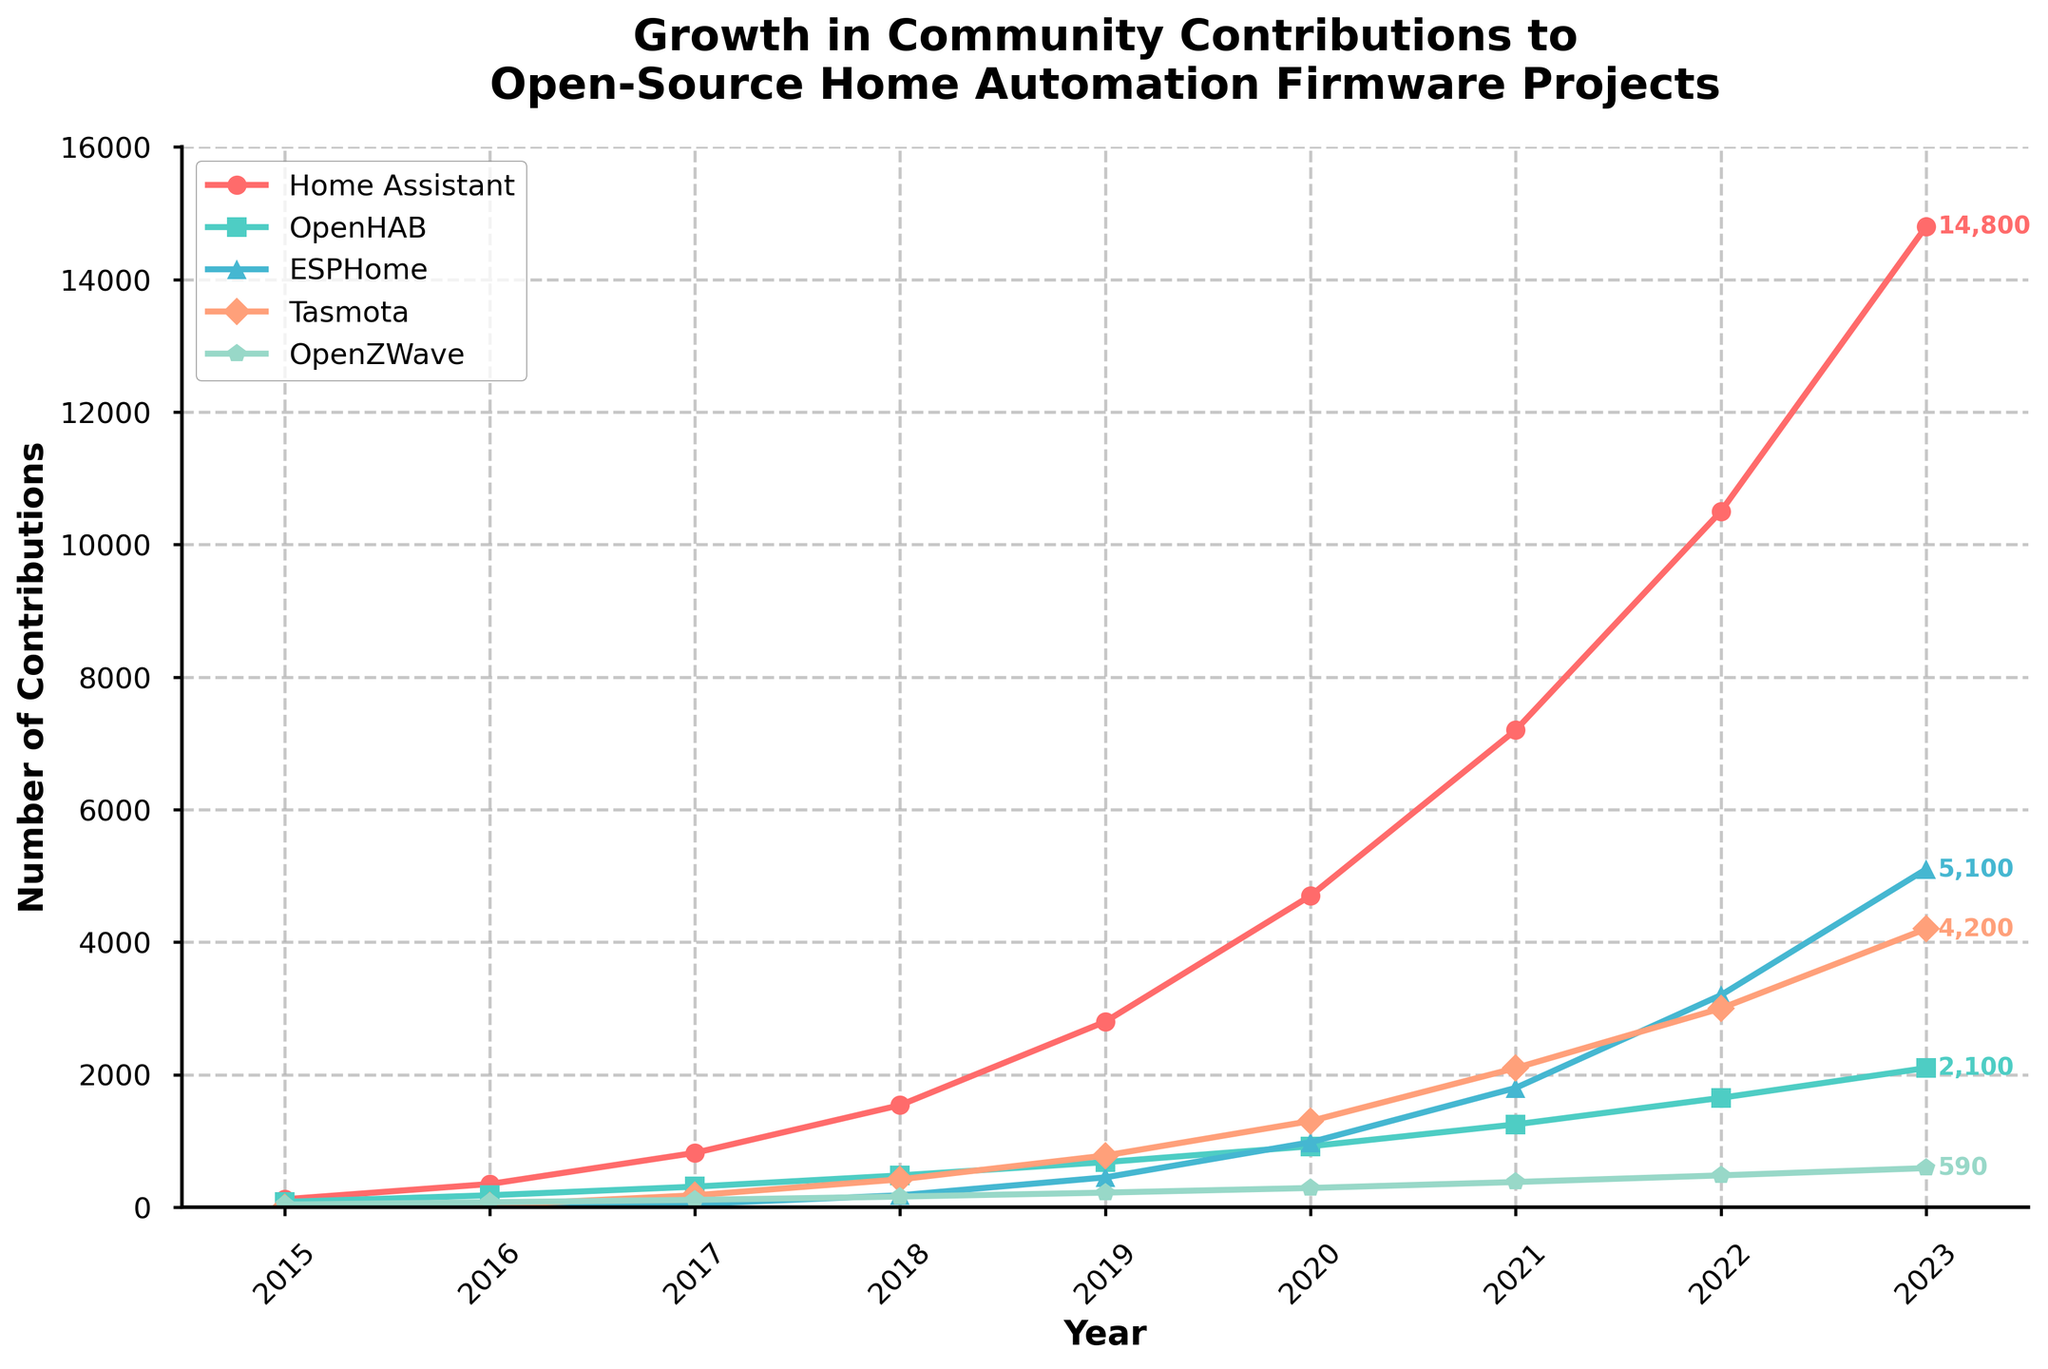Which project had the highest number of contributions in 2023? The chart shows the number of contributions for each project in 2023. By looking at the height of the lines marked for each project on the y-axis, we see that Home Assistant reached the highest value.
Answer: Home Assistant How did the number of contributions to ESPHome in 2021 compare to those in 2020? The chart indicates the number of contributions for ESPHome. For 2020, the contributions were 980, and for 2021, they were 1800. To see the change, subtract the 2020 value from the 2021 value (1800 - 980 = 820).
Answer: Increased by 820 Which two projects had the closest number of contributions in 2019? To find this, look at the contributions for each project in 2019. The contributions are as follows: Home Assistant (2800), OpenHAB (680), ESPHome (450), Tasmota (780), OpenZWave (220). The closest pair are ESPHome (450) and OpenHAB (680) with a difference of 230.
Answer: ESPHome and OpenHAB What is the average number of contributions for Tasmota over the years shown? First, sum the contributions for Tasmota over the years: 0 (2015) + 30 (2016) + 180 (2017) + 420 (2018) + 780 (2019) + 1300 (2020) + 2100 (2021) + 3000 (2022) + 4200 (2023) = 10010. Then divide by the number of years (9).
Answer: 1001.1 Which project showed the most significant growth from 2015 to 2023? Look at the contributions for each project in both 2015 and 2023. Home Assistant grew from 120 to 14800, OpenHAB from 80 to 2100, ESPHome from 0 to 5100, Tasmota from 0 to 4200, OpenZWave from 40 to 590. Home Assistant shows the most significant growth.
Answer: Home Assistant What is the total number of contributions across all projects in 2017? Add up the contributions for all projects in 2017: Home Assistant (820) + OpenHAB (310) + ESPHome (50) + Tasmota (180) + OpenZWave (110). The sum is 820 + 310 + 50 + 180 + 110 = 1470.
Answer: 1470 What color represents OpenHAB in the chart? The chart shows each project in different colors. OpenHAB is represented by the green line.
Answer: Green How many more contributions did Home Assistant have compared to Tasmota in 2022? From the chart, Home Assistant had 10500 contributions in 2022, and Tasmota had 3000. Subtract Tasmota's contributions from Home Assistant's (10500 - 3000).
Answer: 7500 more Between which two consecutive years did OpenZWave see the highest increase in contributions? Reviewing the chart for year-by-year increases for OpenZWave, the highest increase was from 2016 (75) to 2017 (110): 110 - 75 = 35.
Answer: 2016-2017 How does the trend of contributions to Home Assistant compare to that of OpenHAB over the entire period? The trend for Home Assistant shows a consistent and significant increase each year, especially between 2019 and 2023, whereas OpenHAB's increase is slower and more steady.
Answer: Home Assistant shows faster growth 